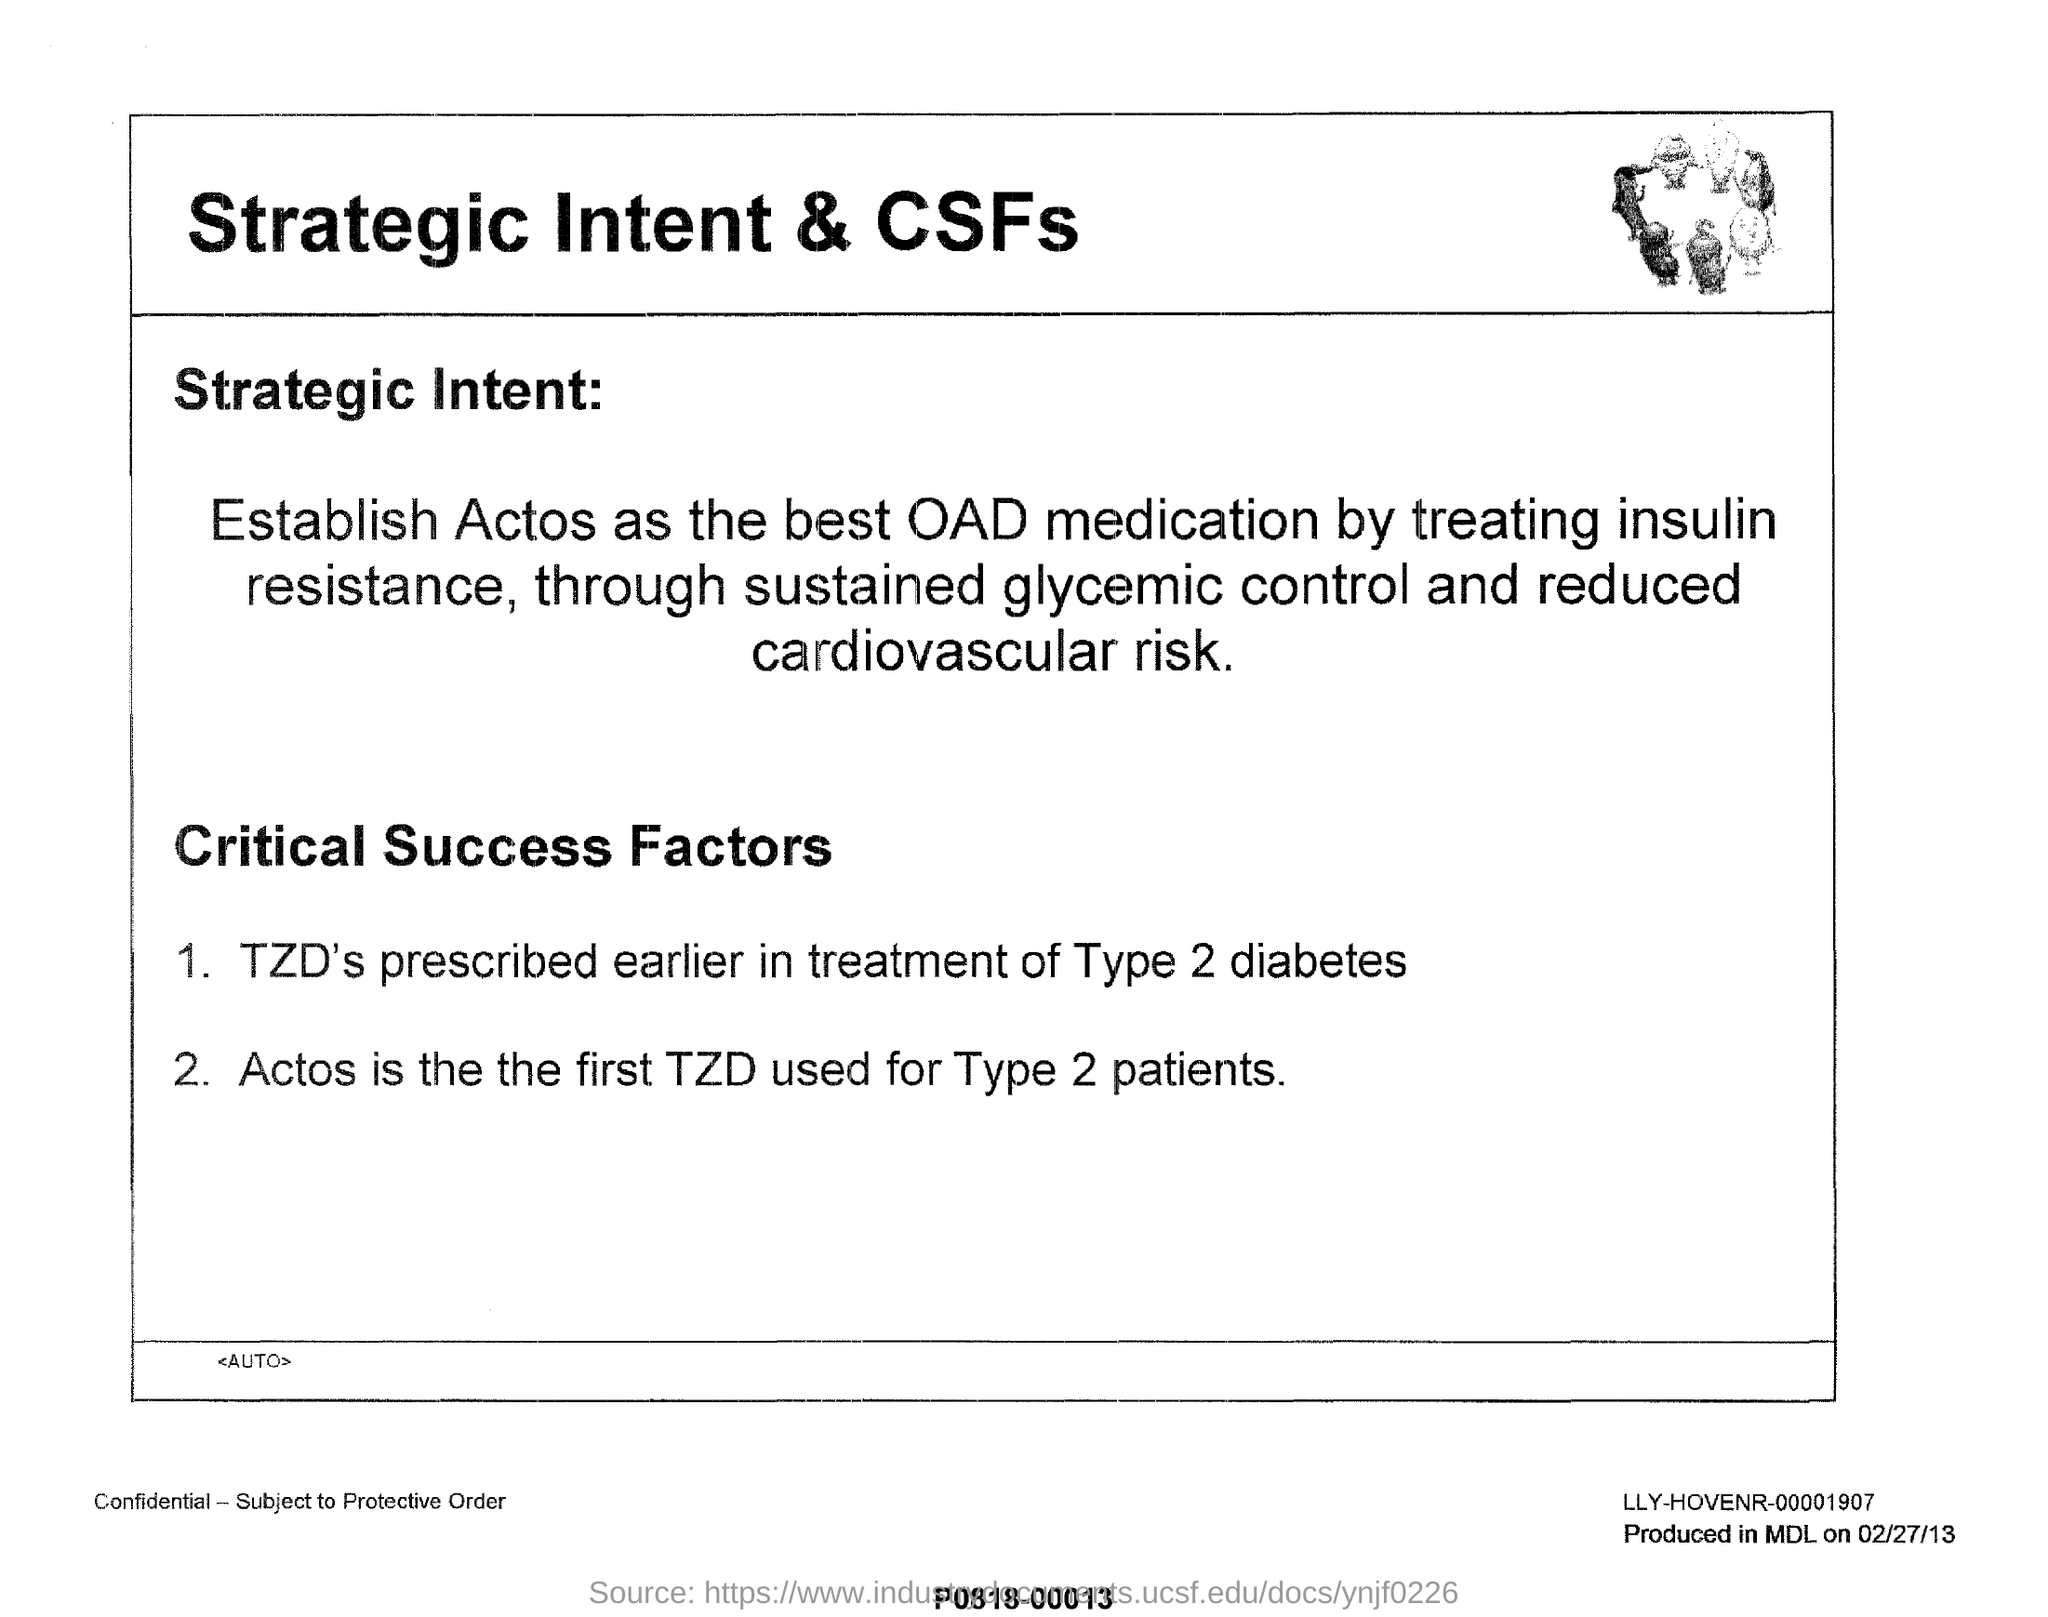List a handful of essential elements in this visual. It has been established that Actos is the best medication for treating insulin resistance as determined by the establishment of its efficacy and safety in clinical trials. For individuals diagnosed with type 2 diabetes, the use of a thiazolidinedione (TZD) medication is often prescribed as part of their treatment plan. Actos is the first TZD used for type 2 diabetes patients. 